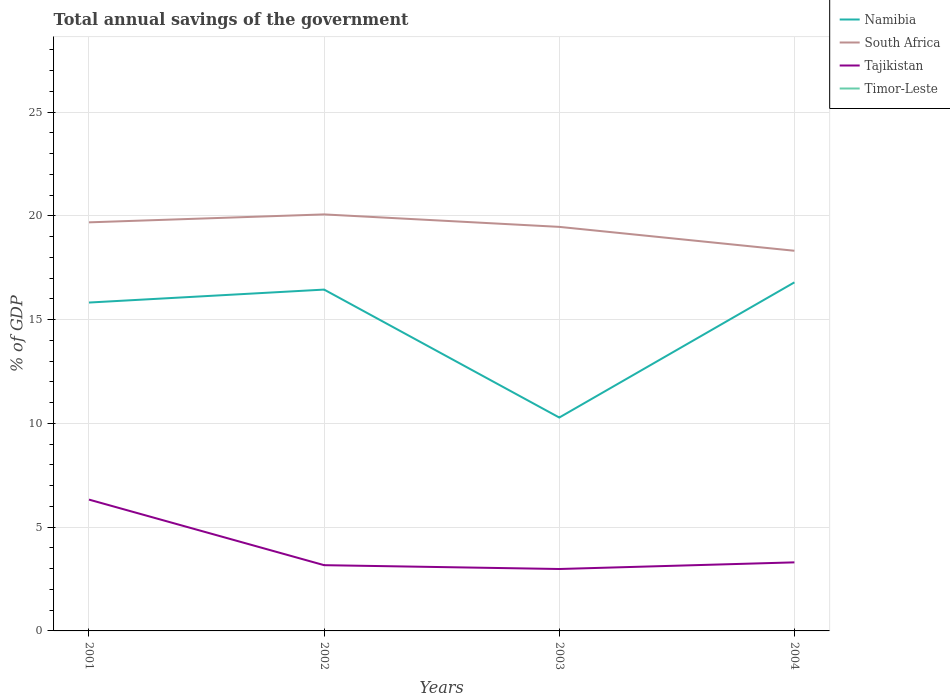Across all years, what is the maximum total annual savings of the government in Namibia?
Give a very brief answer. 10.28. What is the total total annual savings of the government in Tajikistan in the graph?
Provide a succinct answer. -0.32. What is the difference between the highest and the second highest total annual savings of the government in South Africa?
Keep it short and to the point. 1.75. What is the difference between the highest and the lowest total annual savings of the government in South Africa?
Your answer should be very brief. 3. Is the total annual savings of the government in South Africa strictly greater than the total annual savings of the government in Namibia over the years?
Your answer should be compact. No. How many lines are there?
Offer a terse response. 3. How many years are there in the graph?
Your answer should be compact. 4. What is the difference between two consecutive major ticks on the Y-axis?
Ensure brevity in your answer.  5. Does the graph contain any zero values?
Your response must be concise. Yes. Does the graph contain grids?
Provide a succinct answer. Yes. Where does the legend appear in the graph?
Ensure brevity in your answer.  Top right. How are the legend labels stacked?
Provide a succinct answer. Vertical. What is the title of the graph?
Provide a short and direct response. Total annual savings of the government. What is the label or title of the Y-axis?
Ensure brevity in your answer.  % of GDP. What is the % of GDP of Namibia in 2001?
Your answer should be very brief. 15.83. What is the % of GDP in South Africa in 2001?
Make the answer very short. 19.69. What is the % of GDP of Tajikistan in 2001?
Provide a succinct answer. 6.33. What is the % of GDP of Namibia in 2002?
Give a very brief answer. 16.45. What is the % of GDP of South Africa in 2002?
Your answer should be compact. 20.08. What is the % of GDP in Tajikistan in 2002?
Ensure brevity in your answer.  3.17. What is the % of GDP of Timor-Leste in 2002?
Provide a short and direct response. 0. What is the % of GDP in Namibia in 2003?
Your answer should be very brief. 10.28. What is the % of GDP of South Africa in 2003?
Provide a succinct answer. 19.47. What is the % of GDP in Tajikistan in 2003?
Give a very brief answer. 2.98. What is the % of GDP in Timor-Leste in 2003?
Offer a terse response. 0. What is the % of GDP of Namibia in 2004?
Offer a terse response. 16.8. What is the % of GDP of South Africa in 2004?
Make the answer very short. 18.32. What is the % of GDP in Tajikistan in 2004?
Make the answer very short. 3.3. Across all years, what is the maximum % of GDP in Namibia?
Provide a short and direct response. 16.8. Across all years, what is the maximum % of GDP in South Africa?
Give a very brief answer. 20.08. Across all years, what is the maximum % of GDP in Tajikistan?
Give a very brief answer. 6.33. Across all years, what is the minimum % of GDP of Namibia?
Your response must be concise. 10.28. Across all years, what is the minimum % of GDP of South Africa?
Your answer should be very brief. 18.32. Across all years, what is the minimum % of GDP in Tajikistan?
Offer a very short reply. 2.98. What is the total % of GDP in Namibia in the graph?
Provide a succinct answer. 59.36. What is the total % of GDP in South Africa in the graph?
Keep it short and to the point. 77.56. What is the total % of GDP in Tajikistan in the graph?
Provide a succinct answer. 15.79. What is the difference between the % of GDP in Namibia in 2001 and that in 2002?
Offer a terse response. -0.62. What is the difference between the % of GDP of South Africa in 2001 and that in 2002?
Your answer should be compact. -0.38. What is the difference between the % of GDP of Tajikistan in 2001 and that in 2002?
Make the answer very short. 3.16. What is the difference between the % of GDP of Namibia in 2001 and that in 2003?
Your response must be concise. 5.54. What is the difference between the % of GDP in South Africa in 2001 and that in 2003?
Your answer should be very brief. 0.22. What is the difference between the % of GDP in Tajikistan in 2001 and that in 2003?
Your answer should be compact. 3.35. What is the difference between the % of GDP in Namibia in 2001 and that in 2004?
Ensure brevity in your answer.  -0.97. What is the difference between the % of GDP in South Africa in 2001 and that in 2004?
Keep it short and to the point. 1.37. What is the difference between the % of GDP of Tajikistan in 2001 and that in 2004?
Provide a short and direct response. 3.03. What is the difference between the % of GDP of Namibia in 2002 and that in 2003?
Keep it short and to the point. 6.17. What is the difference between the % of GDP in South Africa in 2002 and that in 2003?
Provide a succinct answer. 0.6. What is the difference between the % of GDP of Tajikistan in 2002 and that in 2003?
Offer a terse response. 0.18. What is the difference between the % of GDP of Namibia in 2002 and that in 2004?
Provide a succinct answer. -0.35. What is the difference between the % of GDP in South Africa in 2002 and that in 2004?
Your response must be concise. 1.75. What is the difference between the % of GDP of Tajikistan in 2002 and that in 2004?
Offer a terse response. -0.14. What is the difference between the % of GDP in Namibia in 2003 and that in 2004?
Offer a terse response. -6.52. What is the difference between the % of GDP of South Africa in 2003 and that in 2004?
Offer a very short reply. 1.15. What is the difference between the % of GDP of Tajikistan in 2003 and that in 2004?
Your answer should be very brief. -0.32. What is the difference between the % of GDP of Namibia in 2001 and the % of GDP of South Africa in 2002?
Your answer should be very brief. -4.25. What is the difference between the % of GDP in Namibia in 2001 and the % of GDP in Tajikistan in 2002?
Provide a succinct answer. 12.66. What is the difference between the % of GDP of South Africa in 2001 and the % of GDP of Tajikistan in 2002?
Give a very brief answer. 16.52. What is the difference between the % of GDP of Namibia in 2001 and the % of GDP of South Africa in 2003?
Provide a short and direct response. -3.65. What is the difference between the % of GDP in Namibia in 2001 and the % of GDP in Tajikistan in 2003?
Offer a very short reply. 12.84. What is the difference between the % of GDP of South Africa in 2001 and the % of GDP of Tajikistan in 2003?
Provide a succinct answer. 16.71. What is the difference between the % of GDP of Namibia in 2001 and the % of GDP of South Africa in 2004?
Your answer should be compact. -2.5. What is the difference between the % of GDP in Namibia in 2001 and the % of GDP in Tajikistan in 2004?
Ensure brevity in your answer.  12.52. What is the difference between the % of GDP of South Africa in 2001 and the % of GDP of Tajikistan in 2004?
Offer a very short reply. 16.39. What is the difference between the % of GDP in Namibia in 2002 and the % of GDP in South Africa in 2003?
Offer a very short reply. -3.02. What is the difference between the % of GDP of Namibia in 2002 and the % of GDP of Tajikistan in 2003?
Your answer should be compact. 13.47. What is the difference between the % of GDP in South Africa in 2002 and the % of GDP in Tajikistan in 2003?
Give a very brief answer. 17.09. What is the difference between the % of GDP in Namibia in 2002 and the % of GDP in South Africa in 2004?
Provide a short and direct response. -1.87. What is the difference between the % of GDP in Namibia in 2002 and the % of GDP in Tajikistan in 2004?
Your answer should be very brief. 13.15. What is the difference between the % of GDP of South Africa in 2002 and the % of GDP of Tajikistan in 2004?
Offer a very short reply. 16.77. What is the difference between the % of GDP in Namibia in 2003 and the % of GDP in South Africa in 2004?
Provide a short and direct response. -8.04. What is the difference between the % of GDP in Namibia in 2003 and the % of GDP in Tajikistan in 2004?
Offer a very short reply. 6.98. What is the difference between the % of GDP of South Africa in 2003 and the % of GDP of Tajikistan in 2004?
Your answer should be very brief. 16.17. What is the average % of GDP of Namibia per year?
Give a very brief answer. 14.84. What is the average % of GDP of South Africa per year?
Your response must be concise. 19.39. What is the average % of GDP of Tajikistan per year?
Give a very brief answer. 3.95. What is the average % of GDP of Timor-Leste per year?
Offer a very short reply. 0. In the year 2001, what is the difference between the % of GDP in Namibia and % of GDP in South Africa?
Offer a terse response. -3.87. In the year 2001, what is the difference between the % of GDP in Namibia and % of GDP in Tajikistan?
Make the answer very short. 9.5. In the year 2001, what is the difference between the % of GDP in South Africa and % of GDP in Tajikistan?
Offer a very short reply. 13.36. In the year 2002, what is the difference between the % of GDP of Namibia and % of GDP of South Africa?
Provide a succinct answer. -3.62. In the year 2002, what is the difference between the % of GDP of Namibia and % of GDP of Tajikistan?
Provide a short and direct response. 13.28. In the year 2002, what is the difference between the % of GDP of South Africa and % of GDP of Tajikistan?
Make the answer very short. 16.91. In the year 2003, what is the difference between the % of GDP of Namibia and % of GDP of South Africa?
Provide a succinct answer. -9.19. In the year 2003, what is the difference between the % of GDP in Namibia and % of GDP in Tajikistan?
Make the answer very short. 7.3. In the year 2003, what is the difference between the % of GDP in South Africa and % of GDP in Tajikistan?
Give a very brief answer. 16.49. In the year 2004, what is the difference between the % of GDP in Namibia and % of GDP in South Africa?
Offer a very short reply. -1.52. In the year 2004, what is the difference between the % of GDP in Namibia and % of GDP in Tajikistan?
Ensure brevity in your answer.  13.5. In the year 2004, what is the difference between the % of GDP of South Africa and % of GDP of Tajikistan?
Offer a very short reply. 15.02. What is the ratio of the % of GDP of Namibia in 2001 to that in 2002?
Keep it short and to the point. 0.96. What is the ratio of the % of GDP in South Africa in 2001 to that in 2002?
Provide a succinct answer. 0.98. What is the ratio of the % of GDP in Tajikistan in 2001 to that in 2002?
Offer a terse response. 2. What is the ratio of the % of GDP of Namibia in 2001 to that in 2003?
Provide a succinct answer. 1.54. What is the ratio of the % of GDP of South Africa in 2001 to that in 2003?
Offer a terse response. 1.01. What is the ratio of the % of GDP in Tajikistan in 2001 to that in 2003?
Your answer should be compact. 2.12. What is the ratio of the % of GDP of Namibia in 2001 to that in 2004?
Your answer should be compact. 0.94. What is the ratio of the % of GDP of South Africa in 2001 to that in 2004?
Your response must be concise. 1.07. What is the ratio of the % of GDP in Tajikistan in 2001 to that in 2004?
Offer a terse response. 1.92. What is the ratio of the % of GDP in Namibia in 2002 to that in 2003?
Make the answer very short. 1.6. What is the ratio of the % of GDP in South Africa in 2002 to that in 2003?
Give a very brief answer. 1.03. What is the ratio of the % of GDP in Tajikistan in 2002 to that in 2003?
Ensure brevity in your answer.  1.06. What is the ratio of the % of GDP of Namibia in 2002 to that in 2004?
Offer a very short reply. 0.98. What is the ratio of the % of GDP in South Africa in 2002 to that in 2004?
Your answer should be compact. 1.1. What is the ratio of the % of GDP in Tajikistan in 2002 to that in 2004?
Your response must be concise. 0.96. What is the ratio of the % of GDP in Namibia in 2003 to that in 2004?
Provide a succinct answer. 0.61. What is the ratio of the % of GDP in South Africa in 2003 to that in 2004?
Offer a very short reply. 1.06. What is the ratio of the % of GDP of Tajikistan in 2003 to that in 2004?
Give a very brief answer. 0.9. What is the difference between the highest and the second highest % of GDP in Namibia?
Your answer should be compact. 0.35. What is the difference between the highest and the second highest % of GDP of South Africa?
Your response must be concise. 0.38. What is the difference between the highest and the second highest % of GDP in Tajikistan?
Provide a succinct answer. 3.03. What is the difference between the highest and the lowest % of GDP in Namibia?
Keep it short and to the point. 6.52. What is the difference between the highest and the lowest % of GDP of South Africa?
Ensure brevity in your answer.  1.75. What is the difference between the highest and the lowest % of GDP in Tajikistan?
Give a very brief answer. 3.35. 